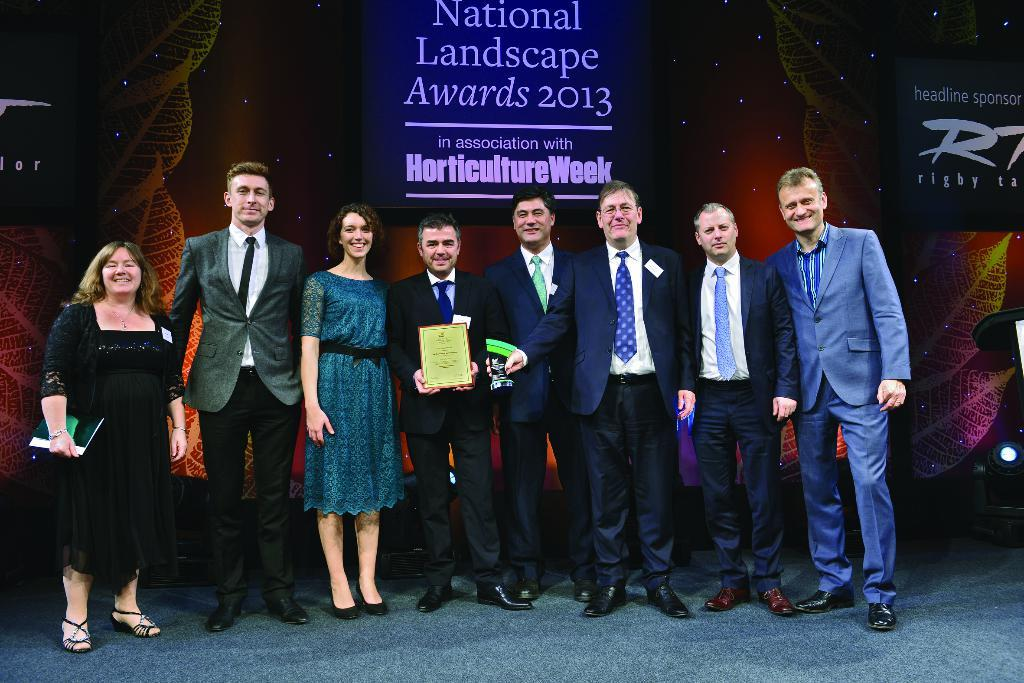How many people are in the image? There are persons standing in the image. What is the surface they are standing on? The persons are standing on the floor. What is one of the persons holding in his hand? One of the persons is holding a certificate in his hand. What can be seen in the background of the image? There is an advertisement in the background of the image. What type of friction can be seen between the persons and the floor in the image? There is no indication of friction between the persons and the floor in the image. Can you hear any sounds coming from the persons in the image? The image is silent, and no sounds can be heard. 